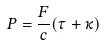<formula> <loc_0><loc_0><loc_500><loc_500>P = \frac { F } { c } ( \tau + \kappa )</formula> 